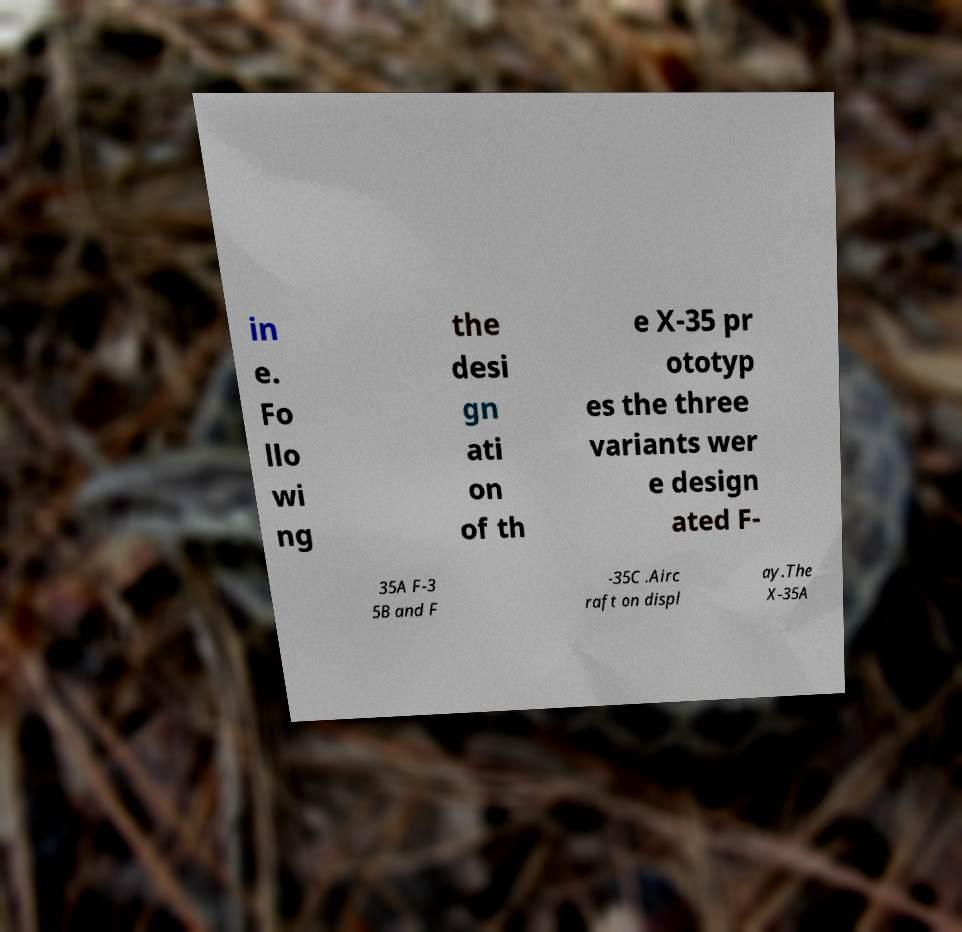Please identify and transcribe the text found in this image. in e. Fo llo wi ng the desi gn ati on of th e X-35 pr ototyp es the three variants wer e design ated F- 35A F-3 5B and F -35C .Airc raft on displ ay.The X-35A 